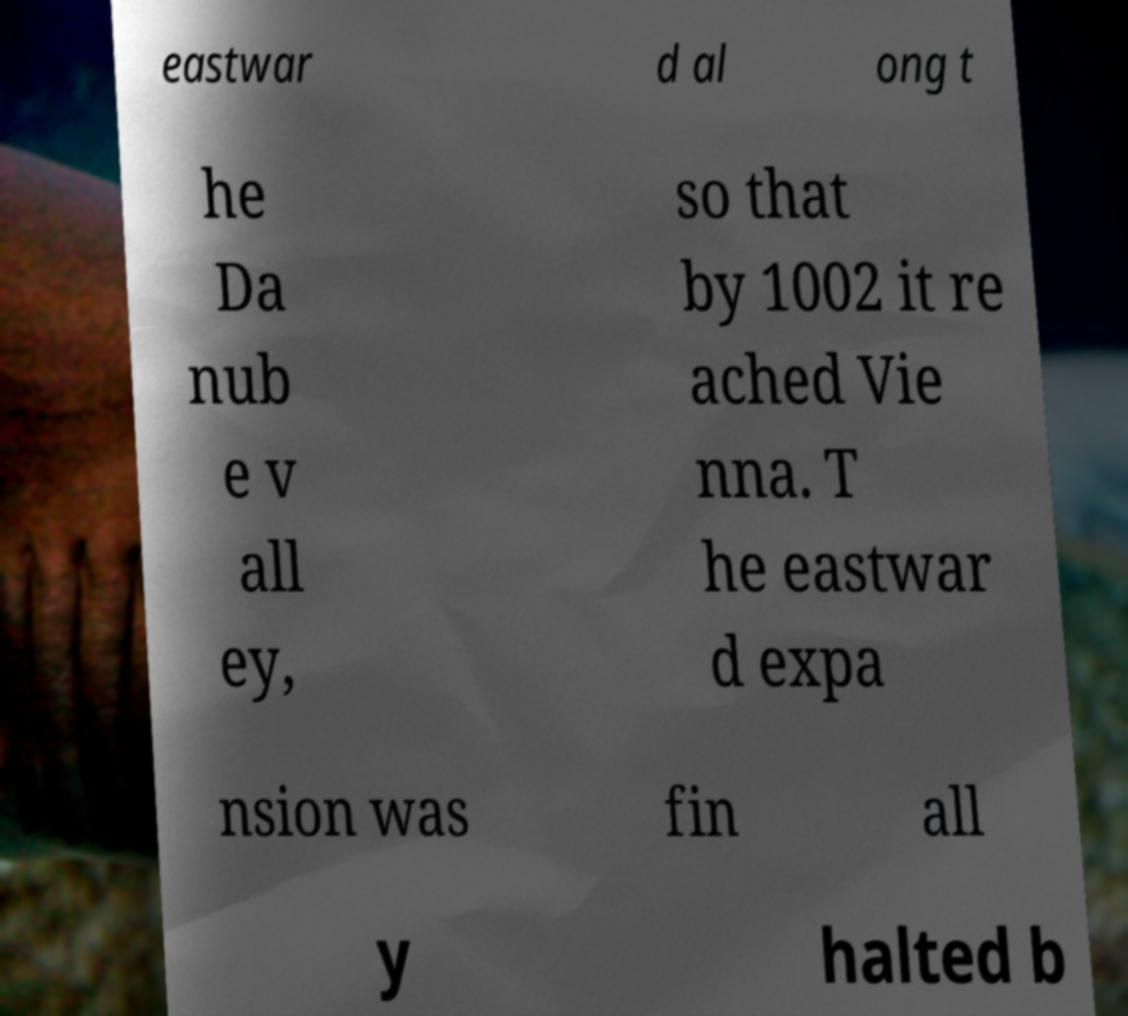What messages or text are displayed in this image? I need them in a readable, typed format. eastwar d al ong t he Da nub e v all ey, so that by 1002 it re ached Vie nna. T he eastwar d expa nsion was fin all y halted b 